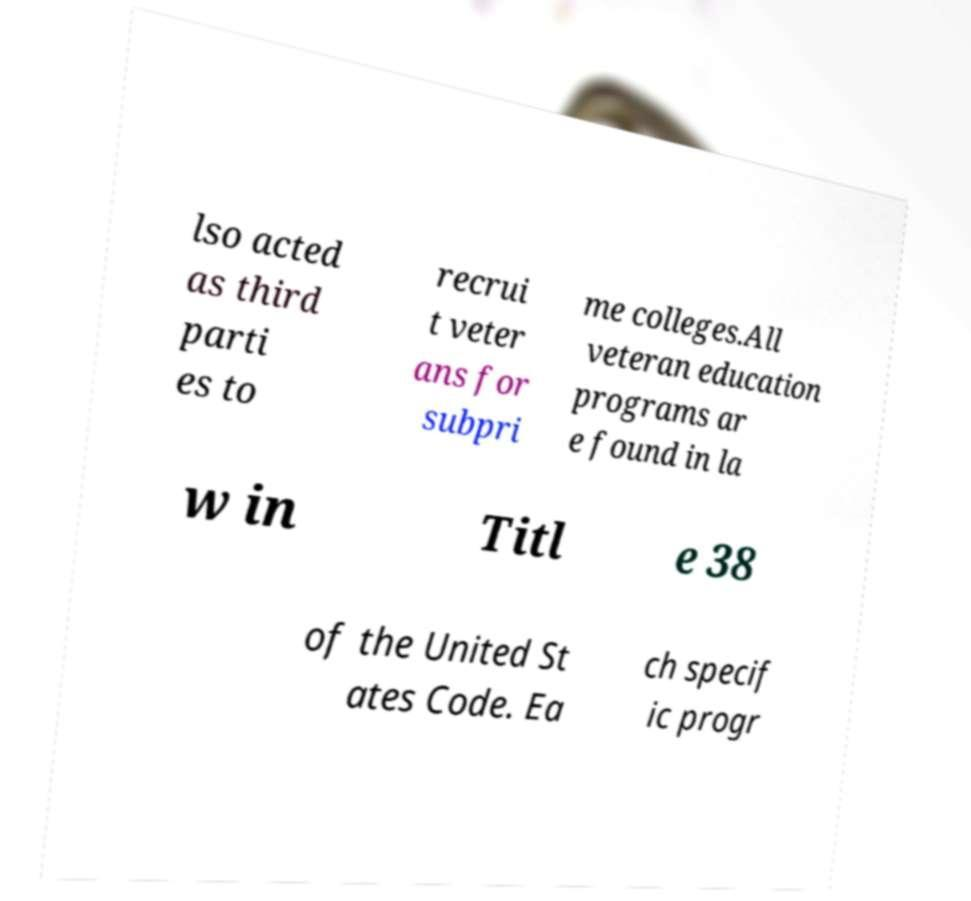What messages or text are displayed in this image? I need them in a readable, typed format. lso acted as third parti es to recrui t veter ans for subpri me colleges.All veteran education programs ar e found in la w in Titl e 38 of the United St ates Code. Ea ch specif ic progr 